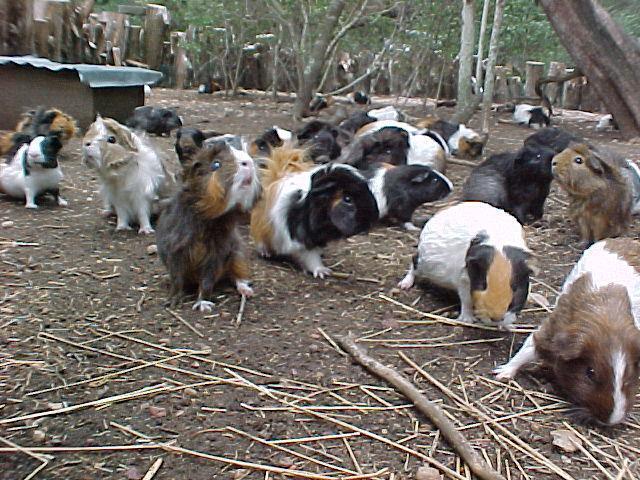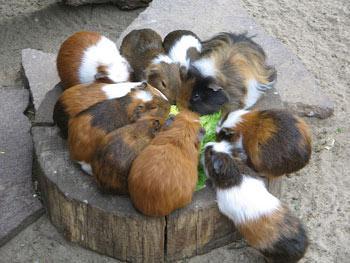The first image is the image on the left, the second image is the image on the right. For the images shown, is this caption "An image shows a horizontal row of no more than five hamsters." true? Answer yes or no. No. The first image is the image on the left, the second image is the image on the right. Assess this claim about the two images: "There are no more than five animals in one of the images". Correct or not? Answer yes or no. No. 